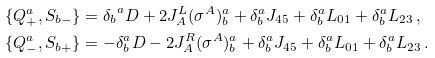Convert formula to latex. <formula><loc_0><loc_0><loc_500><loc_500>\{ Q ^ { a } _ { + } , S _ { b - } \} & = { \delta _ { b } } ^ { a } D + 2 J ^ { L } _ { A } ( \sigma ^ { A } ) ^ { a } _ { b } + \delta ^ { a } _ { b } J _ { 4 5 } + \delta ^ { a } _ { b } L _ { 0 1 } + \delta ^ { a } _ { b } L _ { 2 3 } \, , \\ \{ Q ^ { a } _ { - } , S _ { b + } \} & = - \delta _ { b } ^ { a } D - 2 J ^ { R } _ { A } ( \sigma ^ { A } ) ^ { a } _ { b } + \delta ^ { a } _ { b } J _ { 4 5 } + \delta ^ { a } _ { b } L _ { 0 1 } + \delta ^ { a } _ { b } L _ { 2 3 } \, .</formula> 